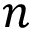<formula> <loc_0><loc_0><loc_500><loc_500>n</formula> 